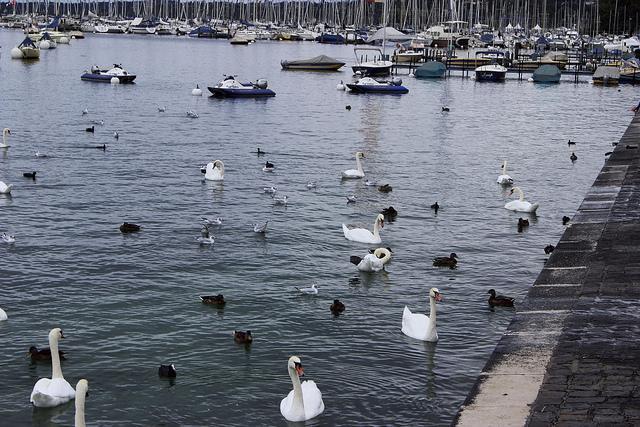How many birds can be seen?
Give a very brief answer. 1. How many people wears a brown tie?
Give a very brief answer. 0. 